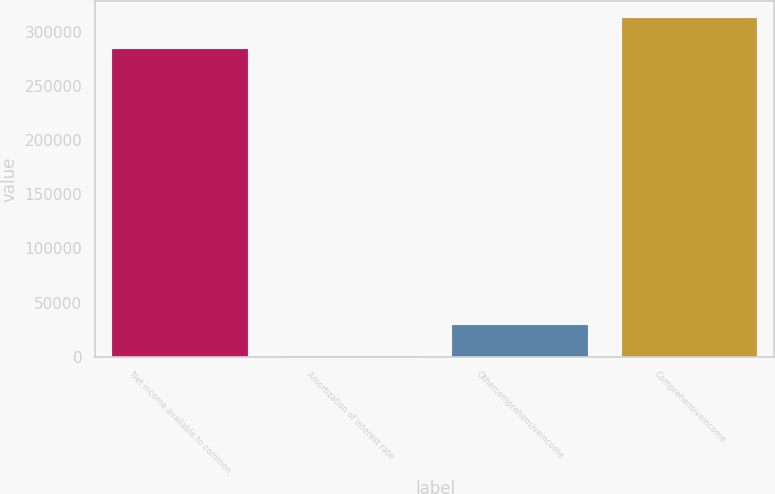Convert chart to OTSL. <chart><loc_0><loc_0><loc_500><loc_500><bar_chart><fcel>Net income available to common<fcel>Amortization of interest rate<fcel>Othercomprehensiveincome<fcel>Comprehensiveincome<nl><fcel>284017<fcel>698<fcel>29099.7<fcel>312419<nl></chart> 